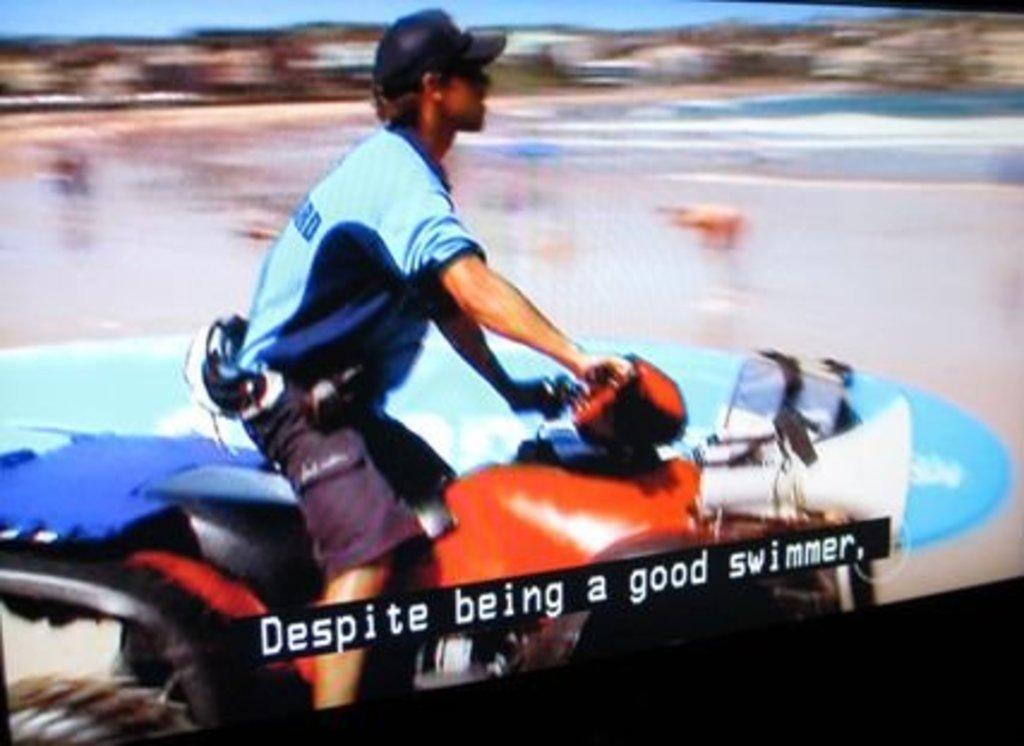Please provide a concise description of this image. In this picture there is a man riding the bike. At the back there is a surfboard and there is water and there are might be buildings. At the top there is sky. At the bottom there is text. 